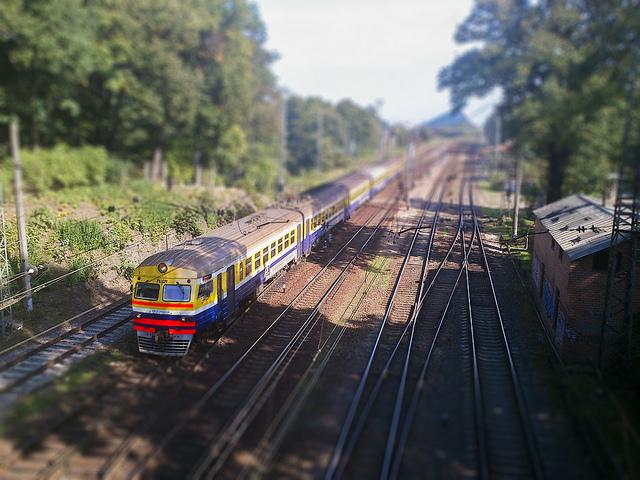Which track is the train on?
Write a very short answer. 2nd from left. What is the purpose of the 3 bright red horizontal stripes on the front of the train?
Give a very brief answer. Safety. Is the train going to let people off here?
Quick response, please. No. 